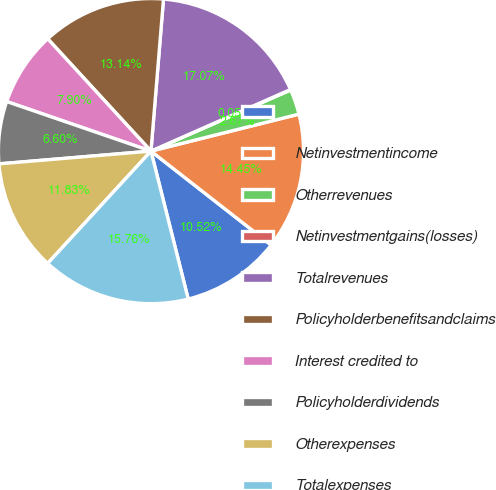<chart> <loc_0><loc_0><loc_500><loc_500><pie_chart><ecel><fcel>Netinvestmentincome<fcel>Otherrevenues<fcel>Netinvestmentgains(losses)<fcel>Totalrevenues<fcel>Policyholderbenefitsandclaims<fcel>Interest credited to<fcel>Policyholderdividends<fcel>Otherexpenses<fcel>Totalexpenses<nl><fcel>10.52%<fcel>14.45%<fcel>2.67%<fcel>0.05%<fcel>17.07%<fcel>13.14%<fcel>7.9%<fcel>6.6%<fcel>11.83%<fcel>15.76%<nl></chart> 